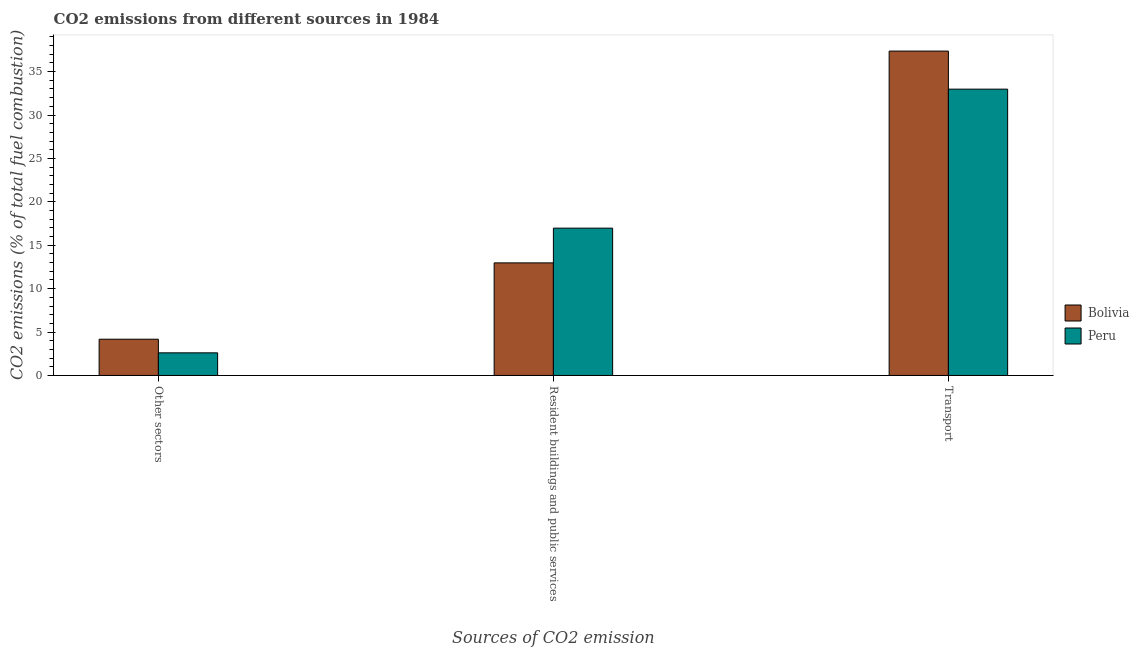How many groups of bars are there?
Your response must be concise. 3. Are the number of bars per tick equal to the number of legend labels?
Your answer should be very brief. Yes. Are the number of bars on each tick of the X-axis equal?
Provide a succinct answer. Yes. What is the label of the 3rd group of bars from the left?
Provide a succinct answer. Transport. What is the percentage of co2 emissions from transport in Peru?
Give a very brief answer. 32.98. Across all countries, what is the maximum percentage of co2 emissions from other sectors?
Your response must be concise. 4.18. Across all countries, what is the minimum percentage of co2 emissions from other sectors?
Keep it short and to the point. 2.61. In which country was the percentage of co2 emissions from transport maximum?
Ensure brevity in your answer.  Bolivia. In which country was the percentage of co2 emissions from other sectors minimum?
Provide a short and direct response. Peru. What is the total percentage of co2 emissions from other sectors in the graph?
Your answer should be compact. 6.78. What is the difference between the percentage of co2 emissions from resident buildings and public services in Bolivia and that in Peru?
Provide a succinct answer. -4. What is the difference between the percentage of co2 emissions from resident buildings and public services in Bolivia and the percentage of co2 emissions from other sectors in Peru?
Keep it short and to the point. 10.36. What is the average percentage of co2 emissions from transport per country?
Your response must be concise. 35.17. What is the difference between the percentage of co2 emissions from resident buildings and public services and percentage of co2 emissions from transport in Peru?
Your answer should be compact. -16.01. In how many countries, is the percentage of co2 emissions from other sectors greater than 21 %?
Provide a short and direct response. 0. What is the ratio of the percentage of co2 emissions from resident buildings and public services in Peru to that in Bolivia?
Give a very brief answer. 1.31. Is the difference between the percentage of co2 emissions from other sectors in Peru and Bolivia greater than the difference between the percentage of co2 emissions from transport in Peru and Bolivia?
Ensure brevity in your answer.  Yes. What is the difference between the highest and the second highest percentage of co2 emissions from transport?
Make the answer very short. 4.38. What is the difference between the highest and the lowest percentage of co2 emissions from other sectors?
Ensure brevity in your answer.  1.57. In how many countries, is the percentage of co2 emissions from other sectors greater than the average percentage of co2 emissions from other sectors taken over all countries?
Your response must be concise. 1. Is the sum of the percentage of co2 emissions from other sectors in Peru and Bolivia greater than the maximum percentage of co2 emissions from resident buildings and public services across all countries?
Your answer should be very brief. No. Are all the bars in the graph horizontal?
Your response must be concise. No. Does the graph contain grids?
Offer a terse response. No. Where does the legend appear in the graph?
Keep it short and to the point. Center right. What is the title of the graph?
Offer a terse response. CO2 emissions from different sources in 1984. What is the label or title of the X-axis?
Make the answer very short. Sources of CO2 emission. What is the label or title of the Y-axis?
Provide a short and direct response. CO2 emissions (% of total fuel combustion). What is the CO2 emissions (% of total fuel combustion) in Bolivia in Other sectors?
Offer a very short reply. 4.18. What is the CO2 emissions (% of total fuel combustion) in Peru in Other sectors?
Offer a very short reply. 2.61. What is the CO2 emissions (% of total fuel combustion) in Bolivia in Resident buildings and public services?
Offer a very short reply. 12.97. What is the CO2 emissions (% of total fuel combustion) of Peru in Resident buildings and public services?
Ensure brevity in your answer.  16.97. What is the CO2 emissions (% of total fuel combustion) in Bolivia in Transport?
Keep it short and to the point. 37.36. What is the CO2 emissions (% of total fuel combustion) of Peru in Transport?
Offer a terse response. 32.98. Across all Sources of CO2 emission, what is the maximum CO2 emissions (% of total fuel combustion) in Bolivia?
Provide a short and direct response. 37.36. Across all Sources of CO2 emission, what is the maximum CO2 emissions (% of total fuel combustion) in Peru?
Your answer should be compact. 32.98. Across all Sources of CO2 emission, what is the minimum CO2 emissions (% of total fuel combustion) in Bolivia?
Offer a terse response. 4.18. Across all Sources of CO2 emission, what is the minimum CO2 emissions (% of total fuel combustion) in Peru?
Provide a succinct answer. 2.61. What is the total CO2 emissions (% of total fuel combustion) in Bolivia in the graph?
Keep it short and to the point. 54.51. What is the total CO2 emissions (% of total fuel combustion) of Peru in the graph?
Make the answer very short. 52.55. What is the difference between the CO2 emissions (% of total fuel combustion) of Bolivia in Other sectors and that in Resident buildings and public services?
Your answer should be compact. -8.79. What is the difference between the CO2 emissions (% of total fuel combustion) in Peru in Other sectors and that in Resident buildings and public services?
Offer a terse response. -14.36. What is the difference between the CO2 emissions (% of total fuel combustion) of Bolivia in Other sectors and that in Transport?
Ensure brevity in your answer.  -33.19. What is the difference between the CO2 emissions (% of total fuel combustion) of Peru in Other sectors and that in Transport?
Keep it short and to the point. -30.37. What is the difference between the CO2 emissions (% of total fuel combustion) of Bolivia in Resident buildings and public services and that in Transport?
Make the answer very short. -24.4. What is the difference between the CO2 emissions (% of total fuel combustion) in Peru in Resident buildings and public services and that in Transport?
Provide a succinct answer. -16.01. What is the difference between the CO2 emissions (% of total fuel combustion) in Bolivia in Other sectors and the CO2 emissions (% of total fuel combustion) in Peru in Resident buildings and public services?
Your answer should be very brief. -12.79. What is the difference between the CO2 emissions (% of total fuel combustion) in Bolivia in Other sectors and the CO2 emissions (% of total fuel combustion) in Peru in Transport?
Offer a very short reply. -28.8. What is the difference between the CO2 emissions (% of total fuel combustion) of Bolivia in Resident buildings and public services and the CO2 emissions (% of total fuel combustion) of Peru in Transport?
Provide a succinct answer. -20.01. What is the average CO2 emissions (% of total fuel combustion) of Bolivia per Sources of CO2 emission?
Ensure brevity in your answer.  18.17. What is the average CO2 emissions (% of total fuel combustion) in Peru per Sources of CO2 emission?
Provide a succinct answer. 17.52. What is the difference between the CO2 emissions (% of total fuel combustion) in Bolivia and CO2 emissions (% of total fuel combustion) in Peru in Other sectors?
Give a very brief answer. 1.57. What is the difference between the CO2 emissions (% of total fuel combustion) of Bolivia and CO2 emissions (% of total fuel combustion) of Peru in Resident buildings and public services?
Your response must be concise. -4. What is the difference between the CO2 emissions (% of total fuel combustion) in Bolivia and CO2 emissions (% of total fuel combustion) in Peru in Transport?
Give a very brief answer. 4.38. What is the ratio of the CO2 emissions (% of total fuel combustion) of Bolivia in Other sectors to that in Resident buildings and public services?
Ensure brevity in your answer.  0.32. What is the ratio of the CO2 emissions (% of total fuel combustion) in Peru in Other sectors to that in Resident buildings and public services?
Offer a terse response. 0.15. What is the ratio of the CO2 emissions (% of total fuel combustion) of Bolivia in Other sectors to that in Transport?
Ensure brevity in your answer.  0.11. What is the ratio of the CO2 emissions (% of total fuel combustion) in Peru in Other sectors to that in Transport?
Make the answer very short. 0.08. What is the ratio of the CO2 emissions (% of total fuel combustion) of Bolivia in Resident buildings and public services to that in Transport?
Give a very brief answer. 0.35. What is the ratio of the CO2 emissions (% of total fuel combustion) of Peru in Resident buildings and public services to that in Transport?
Your answer should be compact. 0.51. What is the difference between the highest and the second highest CO2 emissions (% of total fuel combustion) in Bolivia?
Offer a terse response. 24.4. What is the difference between the highest and the second highest CO2 emissions (% of total fuel combustion) of Peru?
Give a very brief answer. 16.01. What is the difference between the highest and the lowest CO2 emissions (% of total fuel combustion) of Bolivia?
Ensure brevity in your answer.  33.19. What is the difference between the highest and the lowest CO2 emissions (% of total fuel combustion) in Peru?
Offer a very short reply. 30.37. 